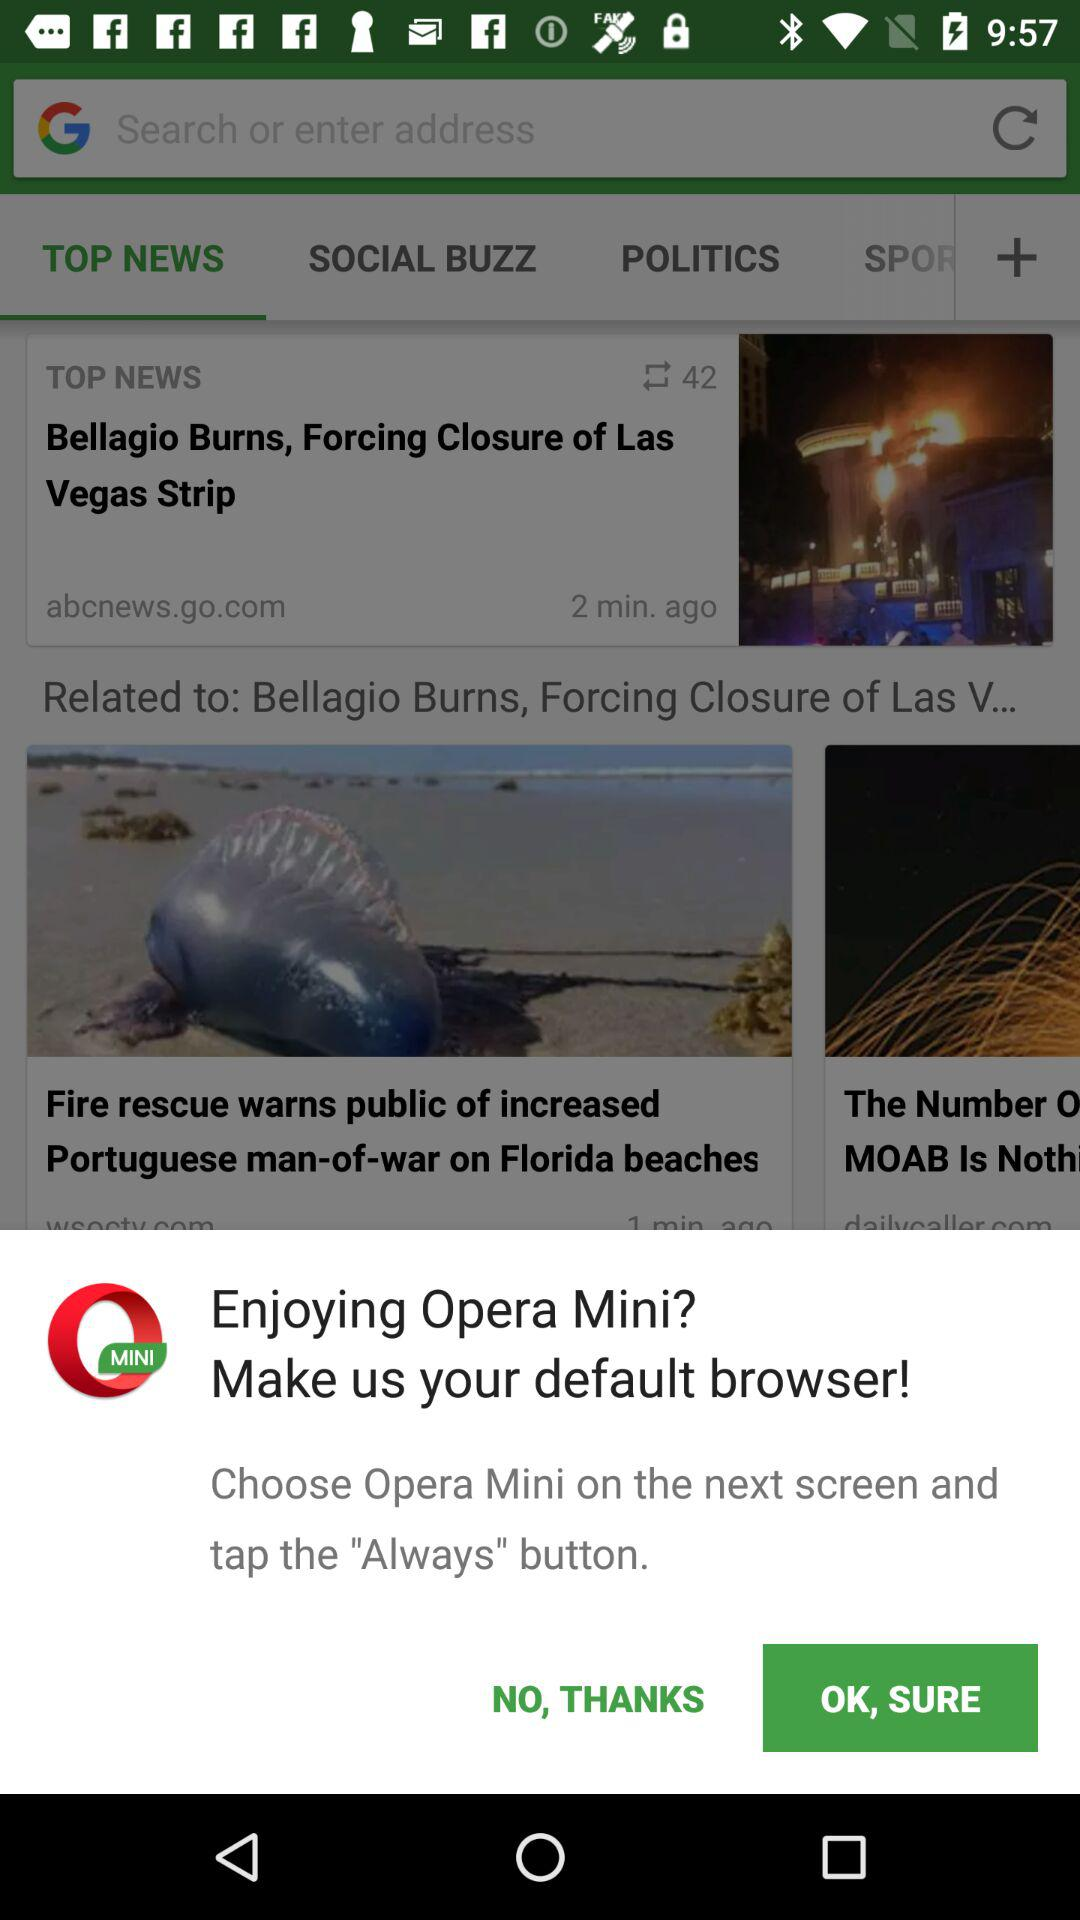What button do we need to tap on the next screen? You need to tap the "Always" button. 